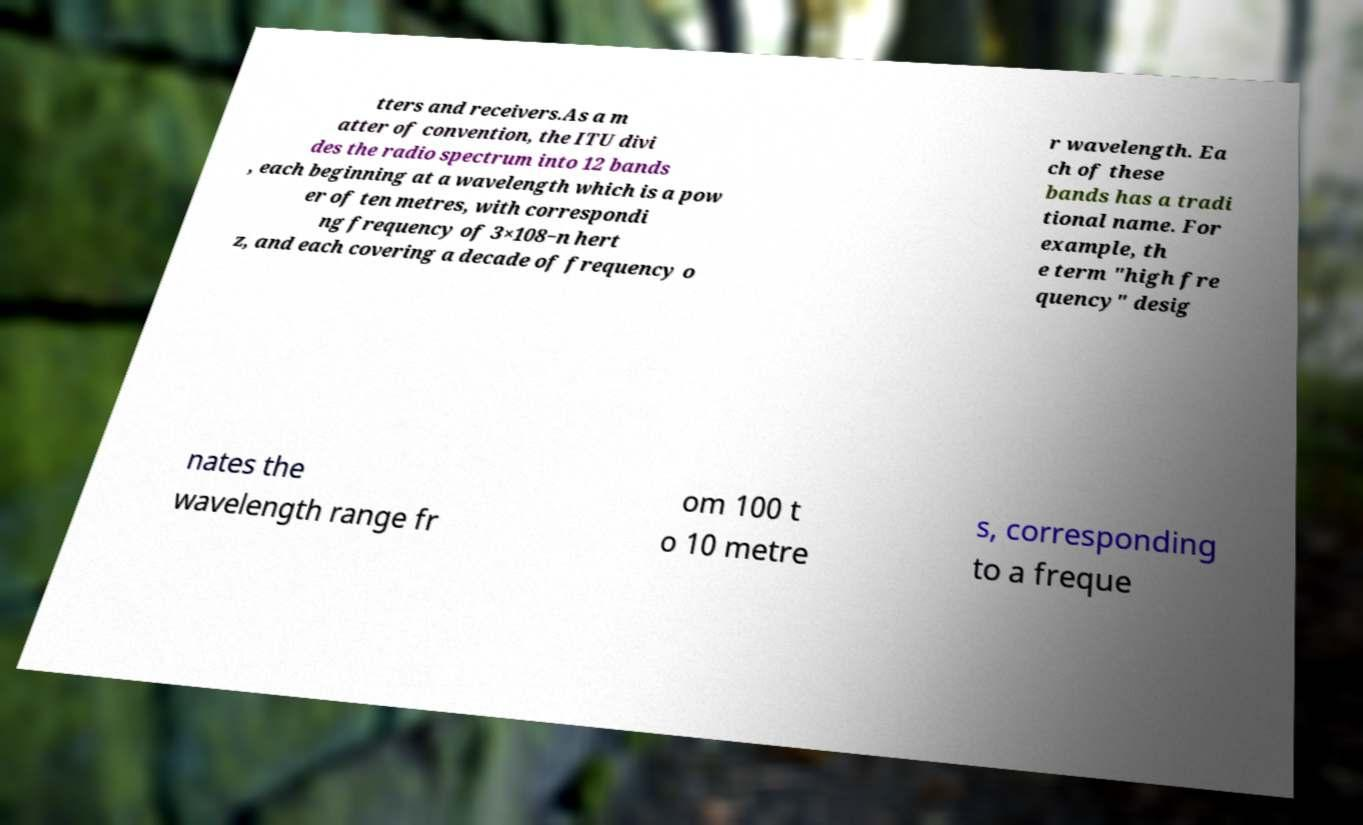I need the written content from this picture converted into text. Can you do that? tters and receivers.As a m atter of convention, the ITU divi des the radio spectrum into 12 bands , each beginning at a wavelength which is a pow er of ten metres, with correspondi ng frequency of 3×108−n hert z, and each covering a decade of frequency o r wavelength. Ea ch of these bands has a tradi tional name. For example, th e term "high fre quency" desig nates the wavelength range fr om 100 t o 10 metre s, corresponding to a freque 